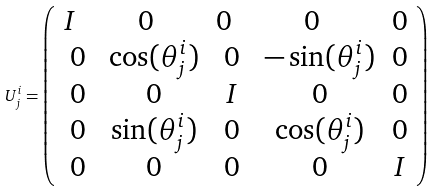Convert formula to latex. <formula><loc_0><loc_0><loc_500><loc_500>U _ { j } ^ { i } = \left ( \begin{array} { c c c c c } I \ \ & 0 \ \ & 0 \ \ & 0 \ \ & 0 \\ 0 & \cos ( \theta _ { j } ^ { i } ) & 0 & - \sin ( \theta _ { j } ^ { i } ) & 0 \\ 0 & 0 & I & 0 & 0 \\ 0 & \sin ( \theta _ { j } ^ { i } ) & 0 & \cos ( \theta _ { j } ^ { i } ) & 0 \\ 0 & 0 & 0 & 0 & I \\ \end{array} \right )</formula> 